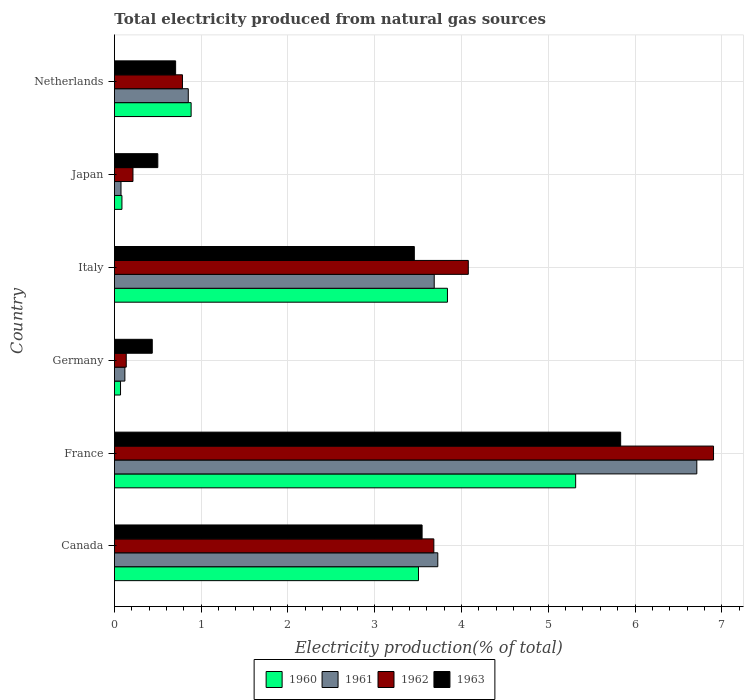Are the number of bars on each tick of the Y-axis equal?
Provide a succinct answer. Yes. What is the label of the 6th group of bars from the top?
Offer a terse response. Canada. In how many cases, is the number of bars for a given country not equal to the number of legend labels?
Your answer should be compact. 0. What is the total electricity produced in 1962 in Italy?
Make the answer very short. 4.08. Across all countries, what is the maximum total electricity produced in 1962?
Provide a short and direct response. 6.91. Across all countries, what is the minimum total electricity produced in 1961?
Provide a succinct answer. 0.08. In which country was the total electricity produced in 1962 maximum?
Offer a very short reply. France. What is the total total electricity produced in 1962 in the graph?
Keep it short and to the point. 15.8. What is the difference between the total electricity produced in 1962 in France and that in Netherlands?
Give a very brief answer. 6.12. What is the difference between the total electricity produced in 1961 in Italy and the total electricity produced in 1963 in Netherlands?
Give a very brief answer. 2.98. What is the average total electricity produced in 1960 per country?
Your answer should be compact. 2.28. What is the difference between the total electricity produced in 1963 and total electricity produced in 1962 in Canada?
Your answer should be compact. -0.14. What is the ratio of the total electricity produced in 1961 in Japan to that in Netherlands?
Offer a terse response. 0.09. Is the difference between the total electricity produced in 1963 in Canada and Italy greater than the difference between the total electricity produced in 1962 in Canada and Italy?
Your answer should be very brief. Yes. What is the difference between the highest and the second highest total electricity produced in 1961?
Keep it short and to the point. 2.99. What is the difference between the highest and the lowest total electricity produced in 1963?
Offer a terse response. 5.4. Is it the case that in every country, the sum of the total electricity produced in 1962 and total electricity produced in 1963 is greater than the sum of total electricity produced in 1960 and total electricity produced in 1961?
Offer a very short reply. No. What does the 2nd bar from the top in Netherlands represents?
Make the answer very short. 1962. What does the 3rd bar from the bottom in France represents?
Your answer should be very brief. 1962. How many bars are there?
Your answer should be compact. 24. How many countries are there in the graph?
Give a very brief answer. 6. What is the difference between two consecutive major ticks on the X-axis?
Offer a terse response. 1. Are the values on the major ticks of X-axis written in scientific E-notation?
Your answer should be compact. No. Does the graph contain grids?
Offer a terse response. Yes. Where does the legend appear in the graph?
Your answer should be compact. Bottom center. How many legend labels are there?
Make the answer very short. 4. What is the title of the graph?
Offer a very short reply. Total electricity produced from natural gas sources. What is the Electricity production(% of total) of 1960 in Canada?
Provide a succinct answer. 3.5. What is the Electricity production(% of total) in 1961 in Canada?
Offer a very short reply. 3.73. What is the Electricity production(% of total) of 1962 in Canada?
Provide a short and direct response. 3.68. What is the Electricity production(% of total) of 1963 in Canada?
Your response must be concise. 3.55. What is the Electricity production(% of total) of 1960 in France?
Make the answer very short. 5.32. What is the Electricity production(% of total) of 1961 in France?
Your answer should be compact. 6.71. What is the Electricity production(% of total) in 1962 in France?
Provide a succinct answer. 6.91. What is the Electricity production(% of total) in 1963 in France?
Keep it short and to the point. 5.83. What is the Electricity production(% of total) of 1960 in Germany?
Give a very brief answer. 0.07. What is the Electricity production(% of total) of 1961 in Germany?
Provide a short and direct response. 0.12. What is the Electricity production(% of total) in 1962 in Germany?
Your answer should be compact. 0.14. What is the Electricity production(% of total) of 1963 in Germany?
Provide a short and direct response. 0.44. What is the Electricity production(% of total) in 1960 in Italy?
Offer a very short reply. 3.84. What is the Electricity production(% of total) in 1961 in Italy?
Your answer should be compact. 3.69. What is the Electricity production(% of total) of 1962 in Italy?
Provide a short and direct response. 4.08. What is the Electricity production(% of total) in 1963 in Italy?
Offer a terse response. 3.46. What is the Electricity production(% of total) in 1960 in Japan?
Offer a very short reply. 0.09. What is the Electricity production(% of total) of 1961 in Japan?
Give a very brief answer. 0.08. What is the Electricity production(% of total) in 1962 in Japan?
Provide a short and direct response. 0.21. What is the Electricity production(% of total) of 1963 in Japan?
Offer a terse response. 0.5. What is the Electricity production(% of total) of 1960 in Netherlands?
Provide a short and direct response. 0.88. What is the Electricity production(% of total) of 1961 in Netherlands?
Offer a terse response. 0.85. What is the Electricity production(% of total) of 1962 in Netherlands?
Make the answer very short. 0.78. What is the Electricity production(% of total) of 1963 in Netherlands?
Keep it short and to the point. 0.71. Across all countries, what is the maximum Electricity production(% of total) of 1960?
Give a very brief answer. 5.32. Across all countries, what is the maximum Electricity production(% of total) of 1961?
Keep it short and to the point. 6.71. Across all countries, what is the maximum Electricity production(% of total) of 1962?
Give a very brief answer. 6.91. Across all countries, what is the maximum Electricity production(% of total) of 1963?
Give a very brief answer. 5.83. Across all countries, what is the minimum Electricity production(% of total) in 1960?
Make the answer very short. 0.07. Across all countries, what is the minimum Electricity production(% of total) of 1961?
Provide a succinct answer. 0.08. Across all countries, what is the minimum Electricity production(% of total) in 1962?
Ensure brevity in your answer.  0.14. Across all countries, what is the minimum Electricity production(% of total) of 1963?
Provide a succinct answer. 0.44. What is the total Electricity production(% of total) in 1960 in the graph?
Ensure brevity in your answer.  13.7. What is the total Electricity production(% of total) in 1961 in the graph?
Your answer should be very brief. 15.17. What is the total Electricity production(% of total) of 1962 in the graph?
Your answer should be very brief. 15.8. What is the total Electricity production(% of total) of 1963 in the graph?
Make the answer very short. 14.48. What is the difference between the Electricity production(% of total) in 1960 in Canada and that in France?
Give a very brief answer. -1.81. What is the difference between the Electricity production(% of total) of 1961 in Canada and that in France?
Make the answer very short. -2.99. What is the difference between the Electricity production(% of total) of 1962 in Canada and that in France?
Offer a terse response. -3.22. What is the difference between the Electricity production(% of total) of 1963 in Canada and that in France?
Keep it short and to the point. -2.29. What is the difference between the Electricity production(% of total) in 1960 in Canada and that in Germany?
Offer a terse response. 3.43. What is the difference between the Electricity production(% of total) in 1961 in Canada and that in Germany?
Offer a very short reply. 3.61. What is the difference between the Electricity production(% of total) in 1962 in Canada and that in Germany?
Ensure brevity in your answer.  3.55. What is the difference between the Electricity production(% of total) in 1963 in Canada and that in Germany?
Your answer should be compact. 3.11. What is the difference between the Electricity production(% of total) in 1960 in Canada and that in Italy?
Provide a succinct answer. -0.33. What is the difference between the Electricity production(% of total) in 1961 in Canada and that in Italy?
Offer a terse response. 0.04. What is the difference between the Electricity production(% of total) in 1962 in Canada and that in Italy?
Your answer should be very brief. -0.4. What is the difference between the Electricity production(% of total) of 1963 in Canada and that in Italy?
Your answer should be compact. 0.09. What is the difference between the Electricity production(% of total) in 1960 in Canada and that in Japan?
Provide a short and direct response. 3.42. What is the difference between the Electricity production(% of total) in 1961 in Canada and that in Japan?
Your answer should be compact. 3.65. What is the difference between the Electricity production(% of total) in 1962 in Canada and that in Japan?
Your answer should be very brief. 3.47. What is the difference between the Electricity production(% of total) in 1963 in Canada and that in Japan?
Ensure brevity in your answer.  3.05. What is the difference between the Electricity production(% of total) in 1960 in Canada and that in Netherlands?
Your answer should be very brief. 2.62. What is the difference between the Electricity production(% of total) in 1961 in Canada and that in Netherlands?
Your answer should be compact. 2.88. What is the difference between the Electricity production(% of total) of 1962 in Canada and that in Netherlands?
Make the answer very short. 2.9. What is the difference between the Electricity production(% of total) of 1963 in Canada and that in Netherlands?
Provide a short and direct response. 2.84. What is the difference between the Electricity production(% of total) of 1960 in France and that in Germany?
Make the answer very short. 5.25. What is the difference between the Electricity production(% of total) of 1961 in France and that in Germany?
Your response must be concise. 6.59. What is the difference between the Electricity production(% of total) in 1962 in France and that in Germany?
Keep it short and to the point. 6.77. What is the difference between the Electricity production(% of total) of 1963 in France and that in Germany?
Ensure brevity in your answer.  5.4. What is the difference between the Electricity production(% of total) of 1960 in France and that in Italy?
Keep it short and to the point. 1.48. What is the difference between the Electricity production(% of total) of 1961 in France and that in Italy?
Provide a succinct answer. 3.03. What is the difference between the Electricity production(% of total) in 1962 in France and that in Italy?
Provide a succinct answer. 2.83. What is the difference between the Electricity production(% of total) in 1963 in France and that in Italy?
Give a very brief answer. 2.38. What is the difference between the Electricity production(% of total) of 1960 in France and that in Japan?
Offer a very short reply. 5.23. What is the difference between the Electricity production(% of total) in 1961 in France and that in Japan?
Keep it short and to the point. 6.64. What is the difference between the Electricity production(% of total) in 1962 in France and that in Japan?
Keep it short and to the point. 6.69. What is the difference between the Electricity production(% of total) of 1963 in France and that in Japan?
Keep it short and to the point. 5.33. What is the difference between the Electricity production(% of total) in 1960 in France and that in Netherlands?
Your answer should be very brief. 4.43. What is the difference between the Electricity production(% of total) of 1961 in France and that in Netherlands?
Give a very brief answer. 5.86. What is the difference between the Electricity production(% of total) in 1962 in France and that in Netherlands?
Provide a succinct answer. 6.12. What is the difference between the Electricity production(% of total) in 1963 in France and that in Netherlands?
Your answer should be compact. 5.13. What is the difference between the Electricity production(% of total) in 1960 in Germany and that in Italy?
Give a very brief answer. -3.77. What is the difference between the Electricity production(% of total) of 1961 in Germany and that in Italy?
Keep it short and to the point. -3.57. What is the difference between the Electricity production(% of total) of 1962 in Germany and that in Italy?
Offer a very short reply. -3.94. What is the difference between the Electricity production(% of total) in 1963 in Germany and that in Italy?
Your response must be concise. -3.02. What is the difference between the Electricity production(% of total) of 1960 in Germany and that in Japan?
Your answer should be very brief. -0.02. What is the difference between the Electricity production(% of total) of 1961 in Germany and that in Japan?
Ensure brevity in your answer.  0.04. What is the difference between the Electricity production(% of total) of 1962 in Germany and that in Japan?
Your answer should be compact. -0.08. What is the difference between the Electricity production(% of total) of 1963 in Germany and that in Japan?
Keep it short and to the point. -0.06. What is the difference between the Electricity production(% of total) in 1960 in Germany and that in Netherlands?
Keep it short and to the point. -0.81. What is the difference between the Electricity production(% of total) in 1961 in Germany and that in Netherlands?
Give a very brief answer. -0.73. What is the difference between the Electricity production(% of total) in 1962 in Germany and that in Netherlands?
Keep it short and to the point. -0.65. What is the difference between the Electricity production(% of total) in 1963 in Germany and that in Netherlands?
Your response must be concise. -0.27. What is the difference between the Electricity production(% of total) of 1960 in Italy and that in Japan?
Offer a very short reply. 3.75. What is the difference between the Electricity production(% of total) of 1961 in Italy and that in Japan?
Provide a short and direct response. 3.61. What is the difference between the Electricity production(% of total) of 1962 in Italy and that in Japan?
Your answer should be very brief. 3.86. What is the difference between the Electricity production(% of total) of 1963 in Italy and that in Japan?
Your answer should be very brief. 2.96. What is the difference between the Electricity production(% of total) of 1960 in Italy and that in Netherlands?
Offer a very short reply. 2.95. What is the difference between the Electricity production(% of total) of 1961 in Italy and that in Netherlands?
Offer a very short reply. 2.83. What is the difference between the Electricity production(% of total) in 1962 in Italy and that in Netherlands?
Keep it short and to the point. 3.29. What is the difference between the Electricity production(% of total) in 1963 in Italy and that in Netherlands?
Provide a succinct answer. 2.75. What is the difference between the Electricity production(% of total) in 1960 in Japan and that in Netherlands?
Your response must be concise. -0.8. What is the difference between the Electricity production(% of total) in 1961 in Japan and that in Netherlands?
Ensure brevity in your answer.  -0.78. What is the difference between the Electricity production(% of total) of 1962 in Japan and that in Netherlands?
Ensure brevity in your answer.  -0.57. What is the difference between the Electricity production(% of total) of 1963 in Japan and that in Netherlands?
Your response must be concise. -0.21. What is the difference between the Electricity production(% of total) in 1960 in Canada and the Electricity production(% of total) in 1961 in France?
Give a very brief answer. -3.21. What is the difference between the Electricity production(% of total) of 1960 in Canada and the Electricity production(% of total) of 1962 in France?
Offer a very short reply. -3.4. What is the difference between the Electricity production(% of total) in 1960 in Canada and the Electricity production(% of total) in 1963 in France?
Provide a succinct answer. -2.33. What is the difference between the Electricity production(% of total) in 1961 in Canada and the Electricity production(% of total) in 1962 in France?
Provide a succinct answer. -3.18. What is the difference between the Electricity production(% of total) of 1961 in Canada and the Electricity production(% of total) of 1963 in France?
Your answer should be compact. -2.11. What is the difference between the Electricity production(% of total) in 1962 in Canada and the Electricity production(% of total) in 1963 in France?
Your answer should be very brief. -2.15. What is the difference between the Electricity production(% of total) of 1960 in Canada and the Electricity production(% of total) of 1961 in Germany?
Your answer should be very brief. 3.38. What is the difference between the Electricity production(% of total) of 1960 in Canada and the Electricity production(% of total) of 1962 in Germany?
Make the answer very short. 3.37. What is the difference between the Electricity production(% of total) in 1960 in Canada and the Electricity production(% of total) in 1963 in Germany?
Keep it short and to the point. 3.07. What is the difference between the Electricity production(% of total) in 1961 in Canada and the Electricity production(% of total) in 1962 in Germany?
Ensure brevity in your answer.  3.59. What is the difference between the Electricity production(% of total) in 1961 in Canada and the Electricity production(% of total) in 1963 in Germany?
Your answer should be compact. 3.29. What is the difference between the Electricity production(% of total) in 1962 in Canada and the Electricity production(% of total) in 1963 in Germany?
Your answer should be compact. 3.25. What is the difference between the Electricity production(% of total) in 1960 in Canada and the Electricity production(% of total) in 1961 in Italy?
Keep it short and to the point. -0.18. What is the difference between the Electricity production(% of total) of 1960 in Canada and the Electricity production(% of total) of 1962 in Italy?
Offer a terse response. -0.57. What is the difference between the Electricity production(% of total) of 1960 in Canada and the Electricity production(% of total) of 1963 in Italy?
Offer a very short reply. 0.05. What is the difference between the Electricity production(% of total) of 1961 in Canada and the Electricity production(% of total) of 1962 in Italy?
Your answer should be compact. -0.35. What is the difference between the Electricity production(% of total) of 1961 in Canada and the Electricity production(% of total) of 1963 in Italy?
Offer a very short reply. 0.27. What is the difference between the Electricity production(% of total) in 1962 in Canada and the Electricity production(% of total) in 1963 in Italy?
Your response must be concise. 0.23. What is the difference between the Electricity production(% of total) in 1960 in Canada and the Electricity production(% of total) in 1961 in Japan?
Offer a terse response. 3.43. What is the difference between the Electricity production(% of total) in 1960 in Canada and the Electricity production(% of total) in 1962 in Japan?
Make the answer very short. 3.29. What is the difference between the Electricity production(% of total) in 1960 in Canada and the Electricity production(% of total) in 1963 in Japan?
Ensure brevity in your answer.  3. What is the difference between the Electricity production(% of total) in 1961 in Canada and the Electricity production(% of total) in 1962 in Japan?
Provide a succinct answer. 3.51. What is the difference between the Electricity production(% of total) of 1961 in Canada and the Electricity production(% of total) of 1963 in Japan?
Provide a succinct answer. 3.23. What is the difference between the Electricity production(% of total) in 1962 in Canada and the Electricity production(% of total) in 1963 in Japan?
Ensure brevity in your answer.  3.18. What is the difference between the Electricity production(% of total) of 1960 in Canada and the Electricity production(% of total) of 1961 in Netherlands?
Offer a terse response. 2.65. What is the difference between the Electricity production(% of total) in 1960 in Canada and the Electricity production(% of total) in 1962 in Netherlands?
Provide a short and direct response. 2.72. What is the difference between the Electricity production(% of total) of 1960 in Canada and the Electricity production(% of total) of 1963 in Netherlands?
Give a very brief answer. 2.8. What is the difference between the Electricity production(% of total) in 1961 in Canada and the Electricity production(% of total) in 1962 in Netherlands?
Provide a short and direct response. 2.94. What is the difference between the Electricity production(% of total) of 1961 in Canada and the Electricity production(% of total) of 1963 in Netherlands?
Offer a terse response. 3.02. What is the difference between the Electricity production(% of total) in 1962 in Canada and the Electricity production(% of total) in 1963 in Netherlands?
Offer a terse response. 2.98. What is the difference between the Electricity production(% of total) of 1960 in France and the Electricity production(% of total) of 1961 in Germany?
Offer a very short reply. 5.2. What is the difference between the Electricity production(% of total) of 1960 in France and the Electricity production(% of total) of 1962 in Germany?
Make the answer very short. 5.18. What is the difference between the Electricity production(% of total) of 1960 in France and the Electricity production(% of total) of 1963 in Germany?
Give a very brief answer. 4.88. What is the difference between the Electricity production(% of total) of 1961 in France and the Electricity production(% of total) of 1962 in Germany?
Offer a terse response. 6.58. What is the difference between the Electricity production(% of total) in 1961 in France and the Electricity production(% of total) in 1963 in Germany?
Offer a terse response. 6.28. What is the difference between the Electricity production(% of total) of 1962 in France and the Electricity production(% of total) of 1963 in Germany?
Ensure brevity in your answer.  6.47. What is the difference between the Electricity production(% of total) in 1960 in France and the Electricity production(% of total) in 1961 in Italy?
Give a very brief answer. 1.63. What is the difference between the Electricity production(% of total) in 1960 in France and the Electricity production(% of total) in 1962 in Italy?
Give a very brief answer. 1.24. What is the difference between the Electricity production(% of total) in 1960 in France and the Electricity production(% of total) in 1963 in Italy?
Give a very brief answer. 1.86. What is the difference between the Electricity production(% of total) of 1961 in France and the Electricity production(% of total) of 1962 in Italy?
Offer a very short reply. 2.63. What is the difference between the Electricity production(% of total) in 1961 in France and the Electricity production(% of total) in 1963 in Italy?
Ensure brevity in your answer.  3.26. What is the difference between the Electricity production(% of total) in 1962 in France and the Electricity production(% of total) in 1963 in Italy?
Give a very brief answer. 3.45. What is the difference between the Electricity production(% of total) in 1960 in France and the Electricity production(% of total) in 1961 in Japan?
Offer a terse response. 5.24. What is the difference between the Electricity production(% of total) in 1960 in France and the Electricity production(% of total) in 1962 in Japan?
Your answer should be very brief. 5.1. What is the difference between the Electricity production(% of total) of 1960 in France and the Electricity production(% of total) of 1963 in Japan?
Offer a very short reply. 4.82. What is the difference between the Electricity production(% of total) of 1961 in France and the Electricity production(% of total) of 1962 in Japan?
Your answer should be very brief. 6.5. What is the difference between the Electricity production(% of total) in 1961 in France and the Electricity production(% of total) in 1963 in Japan?
Your answer should be compact. 6.21. What is the difference between the Electricity production(% of total) in 1962 in France and the Electricity production(% of total) in 1963 in Japan?
Give a very brief answer. 6.4. What is the difference between the Electricity production(% of total) in 1960 in France and the Electricity production(% of total) in 1961 in Netherlands?
Your answer should be very brief. 4.46. What is the difference between the Electricity production(% of total) in 1960 in France and the Electricity production(% of total) in 1962 in Netherlands?
Provide a succinct answer. 4.53. What is the difference between the Electricity production(% of total) of 1960 in France and the Electricity production(% of total) of 1963 in Netherlands?
Offer a terse response. 4.61. What is the difference between the Electricity production(% of total) of 1961 in France and the Electricity production(% of total) of 1962 in Netherlands?
Your response must be concise. 5.93. What is the difference between the Electricity production(% of total) in 1961 in France and the Electricity production(% of total) in 1963 in Netherlands?
Make the answer very short. 6.01. What is the difference between the Electricity production(% of total) in 1962 in France and the Electricity production(% of total) in 1963 in Netherlands?
Keep it short and to the point. 6.2. What is the difference between the Electricity production(% of total) of 1960 in Germany and the Electricity production(% of total) of 1961 in Italy?
Ensure brevity in your answer.  -3.62. What is the difference between the Electricity production(% of total) in 1960 in Germany and the Electricity production(% of total) in 1962 in Italy?
Provide a short and direct response. -4.01. What is the difference between the Electricity production(% of total) of 1960 in Germany and the Electricity production(% of total) of 1963 in Italy?
Offer a terse response. -3.39. What is the difference between the Electricity production(% of total) of 1961 in Germany and the Electricity production(% of total) of 1962 in Italy?
Offer a very short reply. -3.96. What is the difference between the Electricity production(% of total) of 1961 in Germany and the Electricity production(% of total) of 1963 in Italy?
Give a very brief answer. -3.34. What is the difference between the Electricity production(% of total) of 1962 in Germany and the Electricity production(% of total) of 1963 in Italy?
Keep it short and to the point. -3.32. What is the difference between the Electricity production(% of total) of 1960 in Germany and the Electricity production(% of total) of 1961 in Japan?
Ensure brevity in your answer.  -0.01. What is the difference between the Electricity production(% of total) of 1960 in Germany and the Electricity production(% of total) of 1962 in Japan?
Provide a succinct answer. -0.14. What is the difference between the Electricity production(% of total) of 1960 in Germany and the Electricity production(% of total) of 1963 in Japan?
Give a very brief answer. -0.43. What is the difference between the Electricity production(% of total) in 1961 in Germany and the Electricity production(% of total) in 1962 in Japan?
Offer a terse response. -0.09. What is the difference between the Electricity production(% of total) of 1961 in Germany and the Electricity production(% of total) of 1963 in Japan?
Provide a succinct answer. -0.38. What is the difference between the Electricity production(% of total) of 1962 in Germany and the Electricity production(% of total) of 1963 in Japan?
Your answer should be compact. -0.36. What is the difference between the Electricity production(% of total) in 1960 in Germany and the Electricity production(% of total) in 1961 in Netherlands?
Your response must be concise. -0.78. What is the difference between the Electricity production(% of total) of 1960 in Germany and the Electricity production(% of total) of 1962 in Netherlands?
Offer a very short reply. -0.71. What is the difference between the Electricity production(% of total) in 1960 in Germany and the Electricity production(% of total) in 1963 in Netherlands?
Your answer should be compact. -0.64. What is the difference between the Electricity production(% of total) in 1961 in Germany and the Electricity production(% of total) in 1962 in Netherlands?
Your response must be concise. -0.66. What is the difference between the Electricity production(% of total) of 1961 in Germany and the Electricity production(% of total) of 1963 in Netherlands?
Provide a succinct answer. -0.58. What is the difference between the Electricity production(% of total) of 1962 in Germany and the Electricity production(% of total) of 1963 in Netherlands?
Provide a short and direct response. -0.57. What is the difference between the Electricity production(% of total) of 1960 in Italy and the Electricity production(% of total) of 1961 in Japan?
Your answer should be compact. 3.76. What is the difference between the Electricity production(% of total) in 1960 in Italy and the Electricity production(% of total) in 1962 in Japan?
Give a very brief answer. 3.62. What is the difference between the Electricity production(% of total) in 1960 in Italy and the Electricity production(% of total) in 1963 in Japan?
Your answer should be very brief. 3.34. What is the difference between the Electricity production(% of total) of 1961 in Italy and the Electricity production(% of total) of 1962 in Japan?
Keep it short and to the point. 3.47. What is the difference between the Electricity production(% of total) of 1961 in Italy and the Electricity production(% of total) of 1963 in Japan?
Your answer should be compact. 3.19. What is the difference between the Electricity production(% of total) in 1962 in Italy and the Electricity production(% of total) in 1963 in Japan?
Your response must be concise. 3.58. What is the difference between the Electricity production(% of total) in 1960 in Italy and the Electricity production(% of total) in 1961 in Netherlands?
Provide a short and direct response. 2.99. What is the difference between the Electricity production(% of total) of 1960 in Italy and the Electricity production(% of total) of 1962 in Netherlands?
Your response must be concise. 3.05. What is the difference between the Electricity production(% of total) of 1960 in Italy and the Electricity production(% of total) of 1963 in Netherlands?
Offer a terse response. 3.13. What is the difference between the Electricity production(% of total) of 1961 in Italy and the Electricity production(% of total) of 1962 in Netherlands?
Keep it short and to the point. 2.9. What is the difference between the Electricity production(% of total) of 1961 in Italy and the Electricity production(% of total) of 1963 in Netherlands?
Offer a terse response. 2.98. What is the difference between the Electricity production(% of total) of 1962 in Italy and the Electricity production(% of total) of 1963 in Netherlands?
Offer a very short reply. 3.37. What is the difference between the Electricity production(% of total) in 1960 in Japan and the Electricity production(% of total) in 1961 in Netherlands?
Your answer should be very brief. -0.76. What is the difference between the Electricity production(% of total) of 1960 in Japan and the Electricity production(% of total) of 1962 in Netherlands?
Ensure brevity in your answer.  -0.7. What is the difference between the Electricity production(% of total) in 1960 in Japan and the Electricity production(% of total) in 1963 in Netherlands?
Offer a terse response. -0.62. What is the difference between the Electricity production(% of total) of 1961 in Japan and the Electricity production(% of total) of 1962 in Netherlands?
Your answer should be compact. -0.71. What is the difference between the Electricity production(% of total) of 1961 in Japan and the Electricity production(% of total) of 1963 in Netherlands?
Offer a very short reply. -0.63. What is the difference between the Electricity production(% of total) of 1962 in Japan and the Electricity production(% of total) of 1963 in Netherlands?
Your answer should be very brief. -0.49. What is the average Electricity production(% of total) in 1960 per country?
Your answer should be very brief. 2.28. What is the average Electricity production(% of total) in 1961 per country?
Give a very brief answer. 2.53. What is the average Electricity production(% of total) of 1962 per country?
Provide a short and direct response. 2.63. What is the average Electricity production(% of total) in 1963 per country?
Your answer should be compact. 2.41. What is the difference between the Electricity production(% of total) in 1960 and Electricity production(% of total) in 1961 in Canada?
Offer a terse response. -0.22. What is the difference between the Electricity production(% of total) in 1960 and Electricity production(% of total) in 1962 in Canada?
Your answer should be compact. -0.18. What is the difference between the Electricity production(% of total) of 1960 and Electricity production(% of total) of 1963 in Canada?
Your response must be concise. -0.04. What is the difference between the Electricity production(% of total) of 1961 and Electricity production(% of total) of 1962 in Canada?
Keep it short and to the point. 0.05. What is the difference between the Electricity production(% of total) of 1961 and Electricity production(% of total) of 1963 in Canada?
Provide a succinct answer. 0.18. What is the difference between the Electricity production(% of total) in 1962 and Electricity production(% of total) in 1963 in Canada?
Ensure brevity in your answer.  0.14. What is the difference between the Electricity production(% of total) of 1960 and Electricity production(% of total) of 1961 in France?
Ensure brevity in your answer.  -1.4. What is the difference between the Electricity production(% of total) of 1960 and Electricity production(% of total) of 1962 in France?
Offer a terse response. -1.59. What is the difference between the Electricity production(% of total) in 1960 and Electricity production(% of total) in 1963 in France?
Ensure brevity in your answer.  -0.52. What is the difference between the Electricity production(% of total) of 1961 and Electricity production(% of total) of 1962 in France?
Your answer should be very brief. -0.19. What is the difference between the Electricity production(% of total) in 1961 and Electricity production(% of total) in 1963 in France?
Make the answer very short. 0.88. What is the difference between the Electricity production(% of total) of 1962 and Electricity production(% of total) of 1963 in France?
Provide a short and direct response. 1.07. What is the difference between the Electricity production(% of total) in 1960 and Electricity production(% of total) in 1961 in Germany?
Provide a short and direct response. -0.05. What is the difference between the Electricity production(% of total) in 1960 and Electricity production(% of total) in 1962 in Germany?
Offer a very short reply. -0.07. What is the difference between the Electricity production(% of total) in 1960 and Electricity production(% of total) in 1963 in Germany?
Keep it short and to the point. -0.37. What is the difference between the Electricity production(% of total) of 1961 and Electricity production(% of total) of 1962 in Germany?
Offer a terse response. -0.02. What is the difference between the Electricity production(% of total) of 1961 and Electricity production(% of total) of 1963 in Germany?
Provide a succinct answer. -0.32. What is the difference between the Electricity production(% of total) of 1962 and Electricity production(% of total) of 1963 in Germany?
Your answer should be compact. -0.3. What is the difference between the Electricity production(% of total) of 1960 and Electricity production(% of total) of 1961 in Italy?
Your answer should be compact. 0.15. What is the difference between the Electricity production(% of total) of 1960 and Electricity production(% of total) of 1962 in Italy?
Provide a succinct answer. -0.24. What is the difference between the Electricity production(% of total) in 1960 and Electricity production(% of total) in 1963 in Italy?
Offer a terse response. 0.38. What is the difference between the Electricity production(% of total) in 1961 and Electricity production(% of total) in 1962 in Italy?
Give a very brief answer. -0.39. What is the difference between the Electricity production(% of total) in 1961 and Electricity production(% of total) in 1963 in Italy?
Keep it short and to the point. 0.23. What is the difference between the Electricity production(% of total) in 1962 and Electricity production(% of total) in 1963 in Italy?
Ensure brevity in your answer.  0.62. What is the difference between the Electricity production(% of total) in 1960 and Electricity production(% of total) in 1961 in Japan?
Provide a succinct answer. 0.01. What is the difference between the Electricity production(% of total) in 1960 and Electricity production(% of total) in 1962 in Japan?
Provide a short and direct response. -0.13. What is the difference between the Electricity production(% of total) of 1960 and Electricity production(% of total) of 1963 in Japan?
Give a very brief answer. -0.41. What is the difference between the Electricity production(% of total) of 1961 and Electricity production(% of total) of 1962 in Japan?
Give a very brief answer. -0.14. What is the difference between the Electricity production(% of total) in 1961 and Electricity production(% of total) in 1963 in Japan?
Your answer should be very brief. -0.42. What is the difference between the Electricity production(% of total) of 1962 and Electricity production(% of total) of 1963 in Japan?
Ensure brevity in your answer.  -0.29. What is the difference between the Electricity production(% of total) in 1960 and Electricity production(% of total) in 1961 in Netherlands?
Your response must be concise. 0.03. What is the difference between the Electricity production(% of total) in 1960 and Electricity production(% of total) in 1962 in Netherlands?
Your answer should be very brief. 0.1. What is the difference between the Electricity production(% of total) of 1960 and Electricity production(% of total) of 1963 in Netherlands?
Offer a very short reply. 0.18. What is the difference between the Electricity production(% of total) in 1961 and Electricity production(% of total) in 1962 in Netherlands?
Your answer should be very brief. 0.07. What is the difference between the Electricity production(% of total) in 1961 and Electricity production(% of total) in 1963 in Netherlands?
Provide a short and direct response. 0.15. What is the difference between the Electricity production(% of total) in 1962 and Electricity production(% of total) in 1963 in Netherlands?
Offer a terse response. 0.08. What is the ratio of the Electricity production(% of total) of 1960 in Canada to that in France?
Make the answer very short. 0.66. What is the ratio of the Electricity production(% of total) in 1961 in Canada to that in France?
Give a very brief answer. 0.56. What is the ratio of the Electricity production(% of total) of 1962 in Canada to that in France?
Your answer should be compact. 0.53. What is the ratio of the Electricity production(% of total) of 1963 in Canada to that in France?
Make the answer very short. 0.61. What is the ratio of the Electricity production(% of total) of 1960 in Canada to that in Germany?
Your response must be concise. 49.85. What is the ratio of the Electricity production(% of total) in 1961 in Canada to that in Germany?
Make the answer very short. 30.98. What is the ratio of the Electricity production(% of total) of 1962 in Canada to that in Germany?
Your answer should be compact. 27.02. What is the ratio of the Electricity production(% of total) in 1963 in Canada to that in Germany?
Your response must be concise. 8.13. What is the ratio of the Electricity production(% of total) in 1960 in Canada to that in Italy?
Provide a short and direct response. 0.91. What is the ratio of the Electricity production(% of total) in 1961 in Canada to that in Italy?
Provide a succinct answer. 1.01. What is the ratio of the Electricity production(% of total) of 1962 in Canada to that in Italy?
Keep it short and to the point. 0.9. What is the ratio of the Electricity production(% of total) of 1963 in Canada to that in Italy?
Offer a very short reply. 1.03. What is the ratio of the Electricity production(% of total) of 1960 in Canada to that in Japan?
Your answer should be very brief. 40.48. What is the ratio of the Electricity production(% of total) of 1961 in Canada to that in Japan?
Provide a short and direct response. 49.23. What is the ratio of the Electricity production(% of total) in 1962 in Canada to that in Japan?
Make the answer very short. 17.23. What is the ratio of the Electricity production(% of total) in 1963 in Canada to that in Japan?
Provide a short and direct response. 7.09. What is the ratio of the Electricity production(% of total) of 1960 in Canada to that in Netherlands?
Ensure brevity in your answer.  3.96. What is the ratio of the Electricity production(% of total) in 1961 in Canada to that in Netherlands?
Your answer should be very brief. 4.38. What is the ratio of the Electricity production(% of total) in 1962 in Canada to that in Netherlands?
Keep it short and to the point. 4.69. What is the ratio of the Electricity production(% of total) in 1963 in Canada to that in Netherlands?
Keep it short and to the point. 5.03. What is the ratio of the Electricity production(% of total) of 1960 in France to that in Germany?
Your answer should be compact. 75.62. What is the ratio of the Electricity production(% of total) in 1961 in France to that in Germany?
Offer a terse response. 55.79. What is the ratio of the Electricity production(% of total) of 1962 in France to that in Germany?
Your answer should be compact. 50.69. What is the ratio of the Electricity production(% of total) of 1963 in France to that in Germany?
Give a very brief answer. 13.38. What is the ratio of the Electricity production(% of total) in 1960 in France to that in Italy?
Your answer should be compact. 1.39. What is the ratio of the Electricity production(% of total) in 1961 in France to that in Italy?
Offer a terse response. 1.82. What is the ratio of the Electricity production(% of total) in 1962 in France to that in Italy?
Your answer should be very brief. 1.69. What is the ratio of the Electricity production(% of total) in 1963 in France to that in Italy?
Provide a succinct answer. 1.69. What is the ratio of the Electricity production(% of total) of 1960 in France to that in Japan?
Your answer should be very brief. 61.4. What is the ratio of the Electricity production(% of total) in 1961 in France to that in Japan?
Provide a succinct answer. 88.67. What is the ratio of the Electricity production(% of total) in 1962 in France to that in Japan?
Make the answer very short. 32.32. What is the ratio of the Electricity production(% of total) of 1963 in France to that in Japan?
Your response must be concise. 11.67. What is the ratio of the Electricity production(% of total) of 1960 in France to that in Netherlands?
Keep it short and to the point. 6.01. What is the ratio of the Electricity production(% of total) of 1961 in France to that in Netherlands?
Your answer should be compact. 7.89. What is the ratio of the Electricity production(% of total) of 1962 in France to that in Netherlands?
Keep it short and to the point. 8.8. What is the ratio of the Electricity production(% of total) of 1963 in France to that in Netherlands?
Keep it short and to the point. 8.27. What is the ratio of the Electricity production(% of total) in 1960 in Germany to that in Italy?
Provide a short and direct response. 0.02. What is the ratio of the Electricity production(% of total) of 1961 in Germany to that in Italy?
Provide a short and direct response. 0.03. What is the ratio of the Electricity production(% of total) in 1962 in Germany to that in Italy?
Give a very brief answer. 0.03. What is the ratio of the Electricity production(% of total) of 1963 in Germany to that in Italy?
Keep it short and to the point. 0.13. What is the ratio of the Electricity production(% of total) of 1960 in Germany to that in Japan?
Offer a terse response. 0.81. What is the ratio of the Electricity production(% of total) of 1961 in Germany to that in Japan?
Provide a short and direct response. 1.59. What is the ratio of the Electricity production(% of total) of 1962 in Germany to that in Japan?
Your response must be concise. 0.64. What is the ratio of the Electricity production(% of total) of 1963 in Germany to that in Japan?
Make the answer very short. 0.87. What is the ratio of the Electricity production(% of total) of 1960 in Germany to that in Netherlands?
Provide a short and direct response. 0.08. What is the ratio of the Electricity production(% of total) of 1961 in Germany to that in Netherlands?
Your answer should be very brief. 0.14. What is the ratio of the Electricity production(% of total) of 1962 in Germany to that in Netherlands?
Provide a short and direct response. 0.17. What is the ratio of the Electricity production(% of total) of 1963 in Germany to that in Netherlands?
Your answer should be very brief. 0.62. What is the ratio of the Electricity production(% of total) in 1960 in Italy to that in Japan?
Make the answer very short. 44.33. What is the ratio of the Electricity production(% of total) of 1961 in Italy to that in Japan?
Give a very brief answer. 48.69. What is the ratio of the Electricity production(% of total) of 1962 in Italy to that in Japan?
Ensure brevity in your answer.  19.09. What is the ratio of the Electricity production(% of total) in 1963 in Italy to that in Japan?
Your response must be concise. 6.91. What is the ratio of the Electricity production(% of total) of 1960 in Italy to that in Netherlands?
Provide a short and direct response. 4.34. What is the ratio of the Electricity production(% of total) in 1961 in Italy to that in Netherlands?
Your response must be concise. 4.33. What is the ratio of the Electricity production(% of total) in 1962 in Italy to that in Netherlands?
Make the answer very short. 5.2. What is the ratio of the Electricity production(% of total) in 1963 in Italy to that in Netherlands?
Give a very brief answer. 4.9. What is the ratio of the Electricity production(% of total) of 1960 in Japan to that in Netherlands?
Provide a succinct answer. 0.1. What is the ratio of the Electricity production(% of total) of 1961 in Japan to that in Netherlands?
Your answer should be compact. 0.09. What is the ratio of the Electricity production(% of total) in 1962 in Japan to that in Netherlands?
Give a very brief answer. 0.27. What is the ratio of the Electricity production(% of total) in 1963 in Japan to that in Netherlands?
Your answer should be compact. 0.71. What is the difference between the highest and the second highest Electricity production(% of total) of 1960?
Keep it short and to the point. 1.48. What is the difference between the highest and the second highest Electricity production(% of total) of 1961?
Ensure brevity in your answer.  2.99. What is the difference between the highest and the second highest Electricity production(% of total) of 1962?
Your response must be concise. 2.83. What is the difference between the highest and the second highest Electricity production(% of total) in 1963?
Offer a terse response. 2.29. What is the difference between the highest and the lowest Electricity production(% of total) of 1960?
Offer a terse response. 5.25. What is the difference between the highest and the lowest Electricity production(% of total) of 1961?
Keep it short and to the point. 6.64. What is the difference between the highest and the lowest Electricity production(% of total) in 1962?
Give a very brief answer. 6.77. What is the difference between the highest and the lowest Electricity production(% of total) of 1963?
Provide a succinct answer. 5.4. 